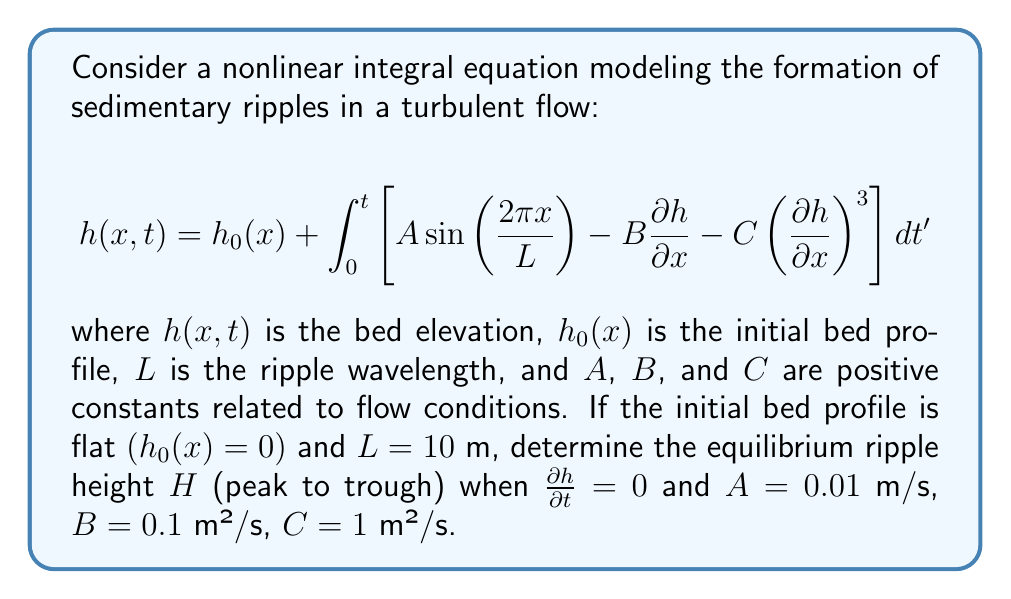Show me your answer to this math problem. To solve this problem, we'll follow these steps:

1) At equilibrium, $\frac{\partial h}{\partial t} = 0$, so the integrand must equal zero:

   $$A \sin\left(\frac{2\pi x}{L}\right) - B\frac{\partial h}{\partial x} - C\left(\frac{\partial h}{\partial x}\right)^3 = 0$$

2) We can assume that the equilibrium profile has the same wavelength as the forcing term:

   $$h(x) = \frac{H}{2} \sin\left(\frac{2\pi x}{L}\right)$$

3) Substituting this into the equation from step 1:

   $$A \sin\left(\frac{2\pi x}{L}\right) - B\frac{H\pi}{L} \cos\left(\frac{2\pi x}{L}\right) - C\left(\frac{H\pi}{L}\right)^3 \cos^3\left(\frac{2\pi x}{L}\right) = 0$$

4) This equation must hold for all $x$. At $x = 0$, $\sin(0) = 0$ and $\cos(0) = 1$, so:

   $$0 - B\frac{H\pi}{L} - C\left(\frac{H\pi}{L}\right)^3 = 0$$

5) Rearranging this equation:

   $$C\left(\frac{H\pi}{L}\right)^3 + B\frac{H\pi}{L} - A = 0$$

6) Substituting the given values $(L = 10$ m, $A = 0.01$ m/s, $B = 0.1$ m²/s, $C = 1$ m²/s$)$:

   $$\left(\frac{H\pi}{10}\right)^3 + 0.1\left(\frac{H\pi}{10}\right) - 0.01 = 0$$

7) This is a cubic equation in $\frac{H\pi}{10}$. Solving it numerically (e.g., using Newton's method) gives:

   $$\frac{H\pi}{10} \approx 0.2166$$

8) Solving for $H$:

   $$H \approx \frac{2.166}{\pi} \approx 0.689 \text{ m}$$
Answer: $H \approx 0.689$ m 